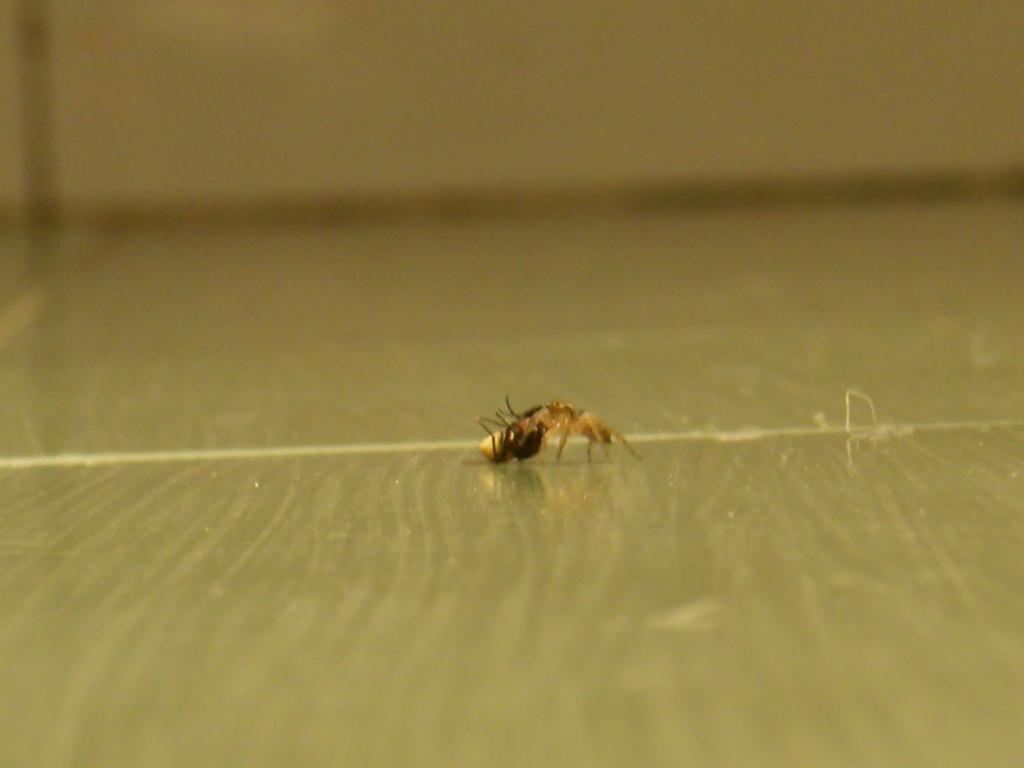What type of creature can be seen in the image? There is an insect in the image. What type of bomb is visible in the image? There is no bomb present in the image; it features an insect. What type of squirrel can be seen interacting with the insect in the image? There is no squirrel present in the image; it only features an insect. 